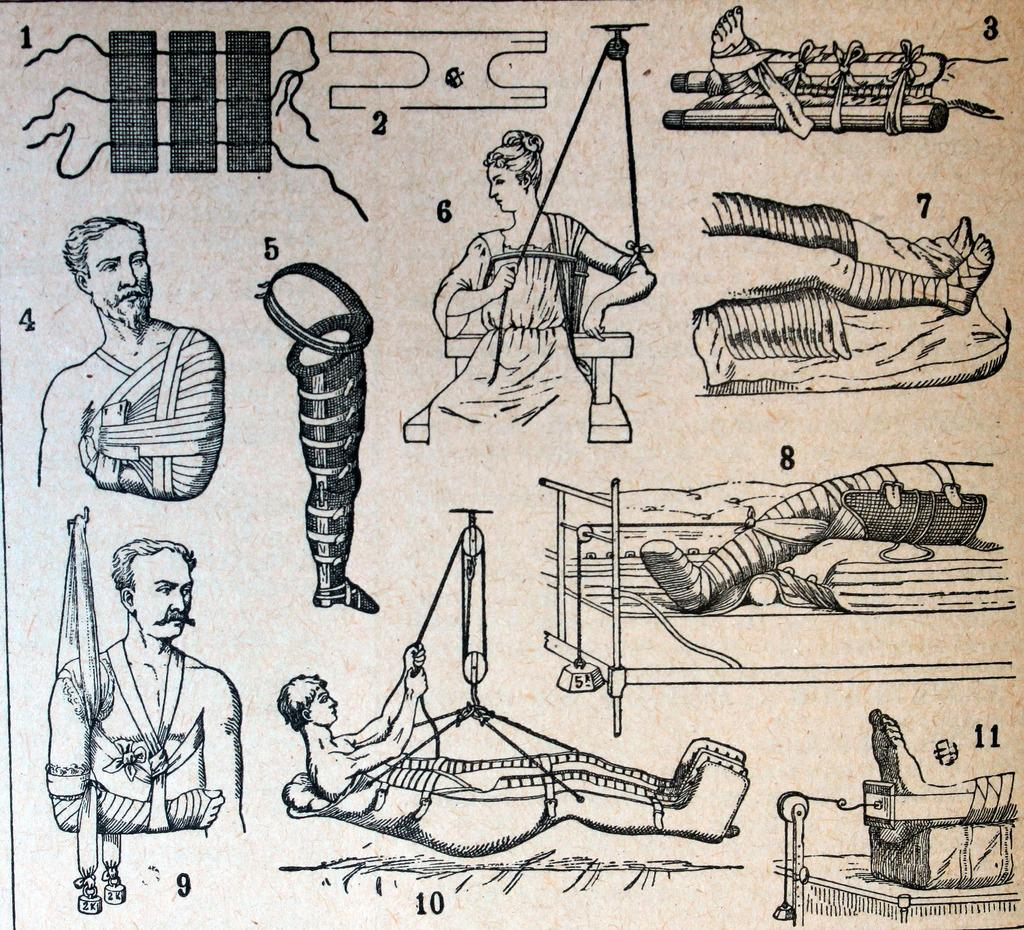What type of image is being described? The image is animated. What can be seen in the image besides the animation? There are numbers, images of persons, and images of objects in the image. Can you see a monkey wearing a sock in the image? There is no monkey or sock present in the image. Is there a gun visible in the image? There is no gun present in the image. 